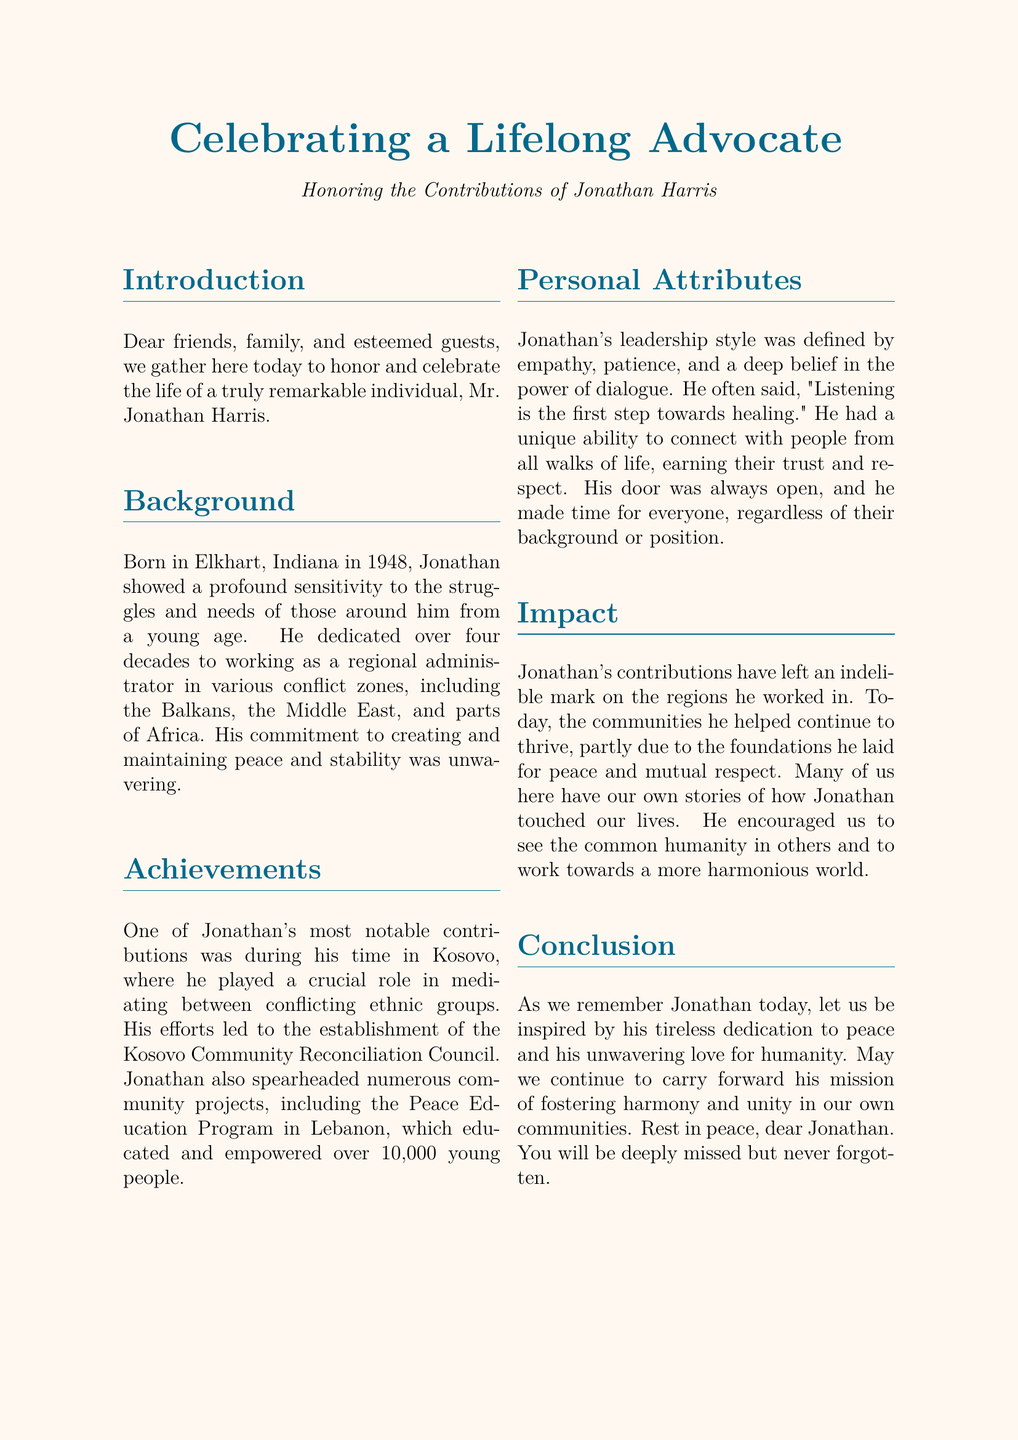What is the name of the individual being honored? The document is a eulogy celebrating the life and contributions of Jonathan Harris.
Answer: Jonathan Harris In which year was Jonathan born? Jonathan Harris was born in Elkhart, Indiana in 1948, as stated in the background section.
Answer: 1948 What program did Jonathan spearhead in Lebanon? The document mentions the Peace Education Program in Lebanon as one of Jonathan's significant contributions.
Answer: Peace Education Program What was Jonathan's role in Kosovo? He played a crucial role in mediating between conflicting ethnic groups in Kosovo, as stated in the achievements section.
Answer: Mediator How many young people were educated by the Peace Education Program? The eulogy states that the program educated and empowered over 10,000 young people.
Answer: Over 10,000 What was a defining characteristic of Jonathan's leadership style? The document highlights that Jonathan's leadership style was defined by empathy, patience, and a deep belief in the power of dialogue.
Answer: Empathy What does the document suggest about Jonathan's impact on the communities? It mentions that the communities he helped continue to thrive due to the foundations he laid for peace and mutual respect.
Answer: Thrive What quote from Jonathan reflects his approach to healing? The quote, "Listening is the first step towards healing," reflects his approach.
Answer: "Listening is the first step towards healing" What legacy did Jonathan leave behind according to the conclusion? The conclusion emphasizes the inspiration to continue fostering harmony and unity in our own communities as his legacy.
Answer: Fostering harmony and unity 